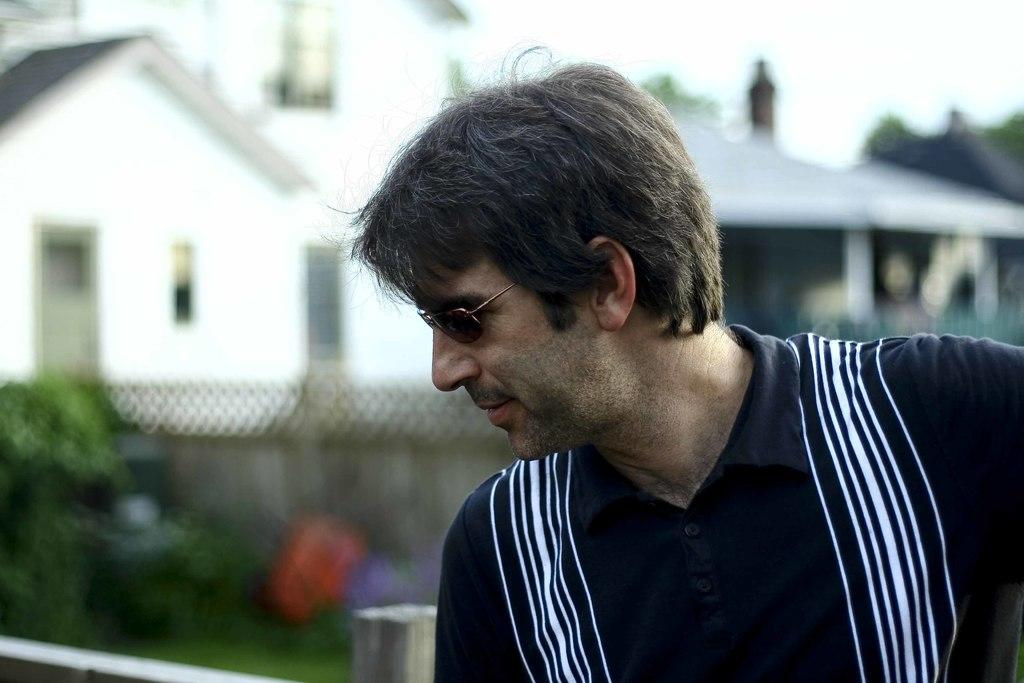Who or what is the main subject in the image? There is a person in the image. What can be seen in the background of the image? There are sheds and trees in the background of the image. What part of the natural environment is visible in the image? The sky is visible in the background of the image. How many cats are visible in the room in the image? There is no room or cats present in the image. 